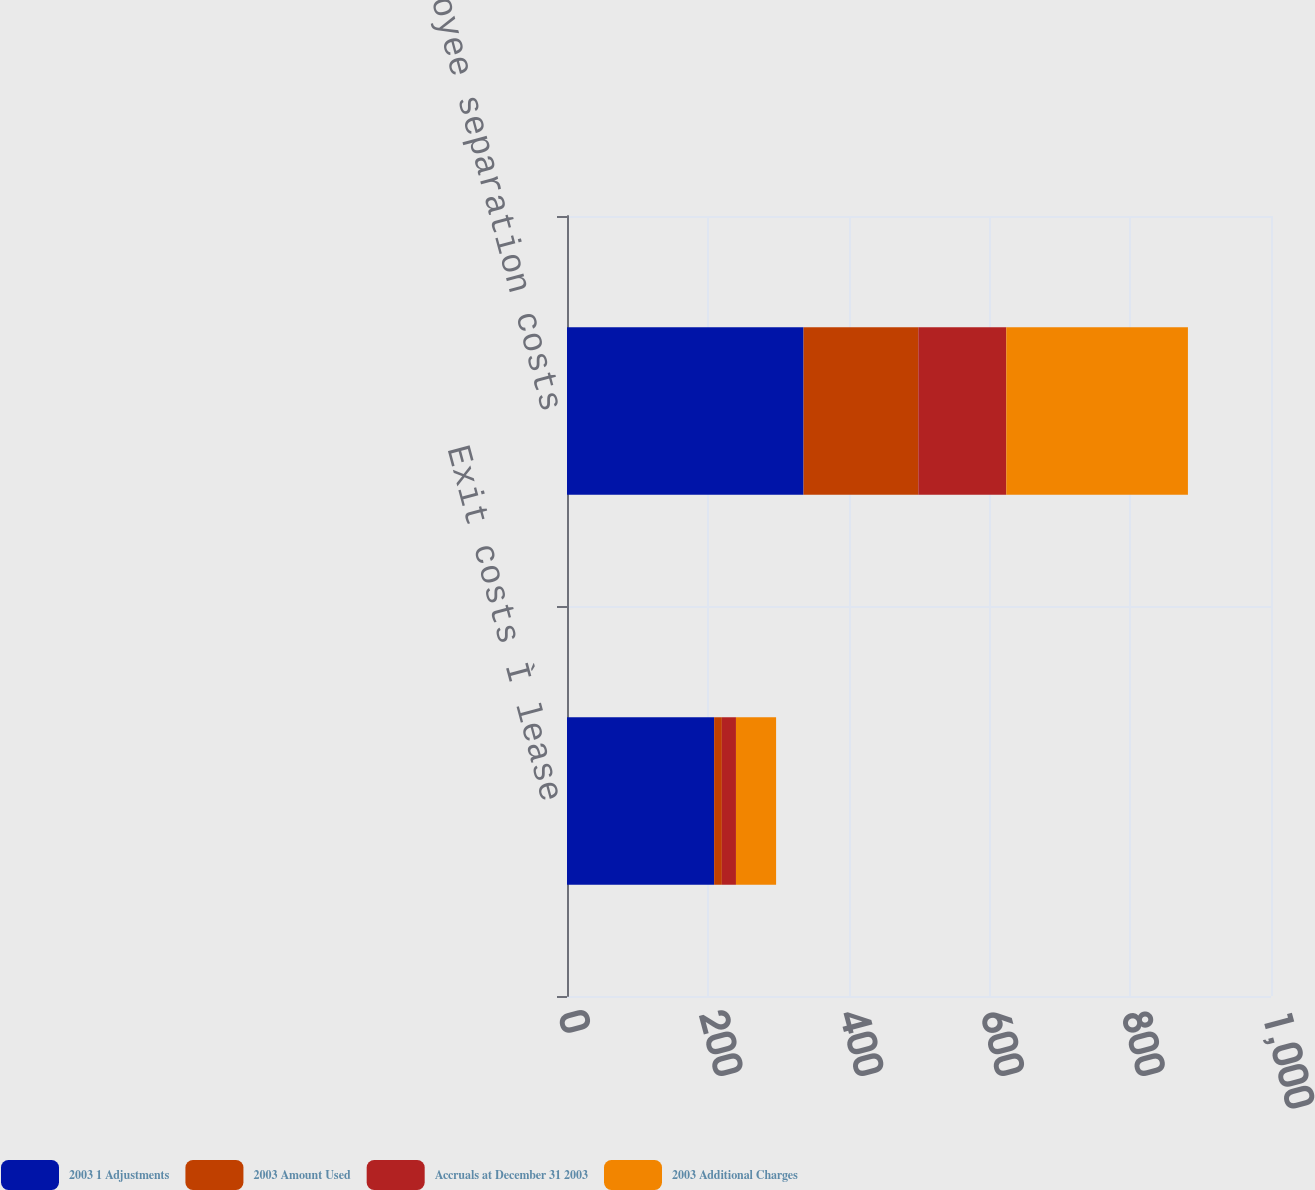Convert chart to OTSL. <chart><loc_0><loc_0><loc_500><loc_500><stacked_bar_chart><ecel><fcel>Exit costs Ì lease<fcel>Employee separation costs<nl><fcel>2003 1 Adjustments<fcel>209<fcel>336<nl><fcel>2003 Amount Used<fcel>11<fcel>163<nl><fcel>Accruals at December 31 2003<fcel>20<fcel>125<nl><fcel>2003 Additional Charges<fcel>57<fcel>258<nl></chart> 